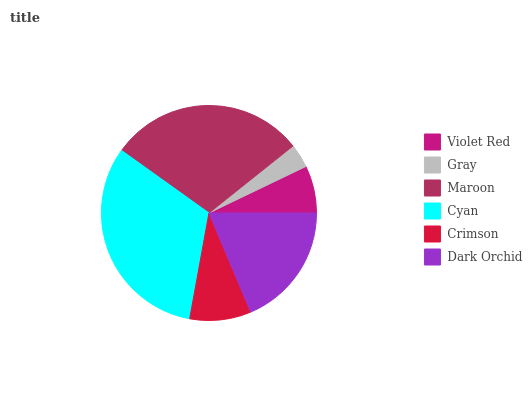Is Gray the minimum?
Answer yes or no. Yes. Is Cyan the maximum?
Answer yes or no. Yes. Is Maroon the minimum?
Answer yes or no. No. Is Maroon the maximum?
Answer yes or no. No. Is Maroon greater than Gray?
Answer yes or no. Yes. Is Gray less than Maroon?
Answer yes or no. Yes. Is Gray greater than Maroon?
Answer yes or no. No. Is Maroon less than Gray?
Answer yes or no. No. Is Dark Orchid the high median?
Answer yes or no. Yes. Is Crimson the low median?
Answer yes or no. Yes. Is Maroon the high median?
Answer yes or no. No. Is Dark Orchid the low median?
Answer yes or no. No. 